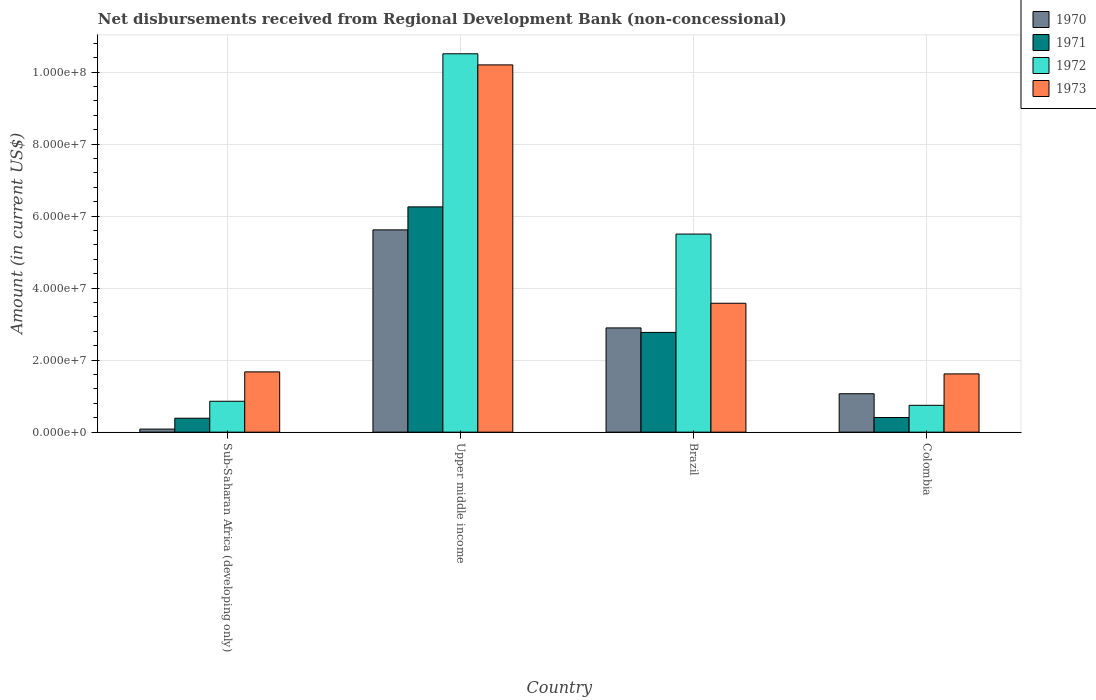Are the number of bars per tick equal to the number of legend labels?
Provide a succinct answer. Yes. How many bars are there on the 2nd tick from the left?
Offer a very short reply. 4. What is the label of the 3rd group of bars from the left?
Give a very brief answer. Brazil. In how many cases, is the number of bars for a given country not equal to the number of legend labels?
Your response must be concise. 0. What is the amount of disbursements received from Regional Development Bank in 1970 in Sub-Saharan Africa (developing only)?
Make the answer very short. 8.50e+05. Across all countries, what is the maximum amount of disbursements received from Regional Development Bank in 1970?
Your response must be concise. 5.62e+07. Across all countries, what is the minimum amount of disbursements received from Regional Development Bank in 1972?
Offer a very short reply. 7.45e+06. In which country was the amount of disbursements received from Regional Development Bank in 1972 maximum?
Make the answer very short. Upper middle income. In which country was the amount of disbursements received from Regional Development Bank in 1971 minimum?
Your answer should be compact. Sub-Saharan Africa (developing only). What is the total amount of disbursements received from Regional Development Bank in 1970 in the graph?
Offer a very short reply. 9.67e+07. What is the difference between the amount of disbursements received from Regional Development Bank in 1970 in Brazil and that in Sub-Saharan Africa (developing only)?
Your answer should be very brief. 2.81e+07. What is the difference between the amount of disbursements received from Regional Development Bank in 1971 in Upper middle income and the amount of disbursements received from Regional Development Bank in 1972 in Colombia?
Offer a very short reply. 5.51e+07. What is the average amount of disbursements received from Regional Development Bank in 1971 per country?
Give a very brief answer. 2.46e+07. What is the difference between the amount of disbursements received from Regional Development Bank of/in 1972 and amount of disbursements received from Regional Development Bank of/in 1973 in Colombia?
Your answer should be compact. -8.73e+06. In how many countries, is the amount of disbursements received from Regional Development Bank in 1971 greater than 84000000 US$?
Your response must be concise. 0. What is the ratio of the amount of disbursements received from Regional Development Bank in 1972 in Colombia to that in Upper middle income?
Offer a very short reply. 0.07. Is the difference between the amount of disbursements received from Regional Development Bank in 1972 in Colombia and Sub-Saharan Africa (developing only) greater than the difference between the amount of disbursements received from Regional Development Bank in 1973 in Colombia and Sub-Saharan Africa (developing only)?
Your response must be concise. No. What is the difference between the highest and the second highest amount of disbursements received from Regional Development Bank in 1971?
Keep it short and to the point. 5.85e+07. What is the difference between the highest and the lowest amount of disbursements received from Regional Development Bank in 1970?
Your response must be concise. 5.53e+07. In how many countries, is the amount of disbursements received from Regional Development Bank in 1970 greater than the average amount of disbursements received from Regional Development Bank in 1970 taken over all countries?
Your answer should be compact. 2. Is the sum of the amount of disbursements received from Regional Development Bank in 1973 in Brazil and Colombia greater than the maximum amount of disbursements received from Regional Development Bank in 1971 across all countries?
Provide a short and direct response. No. Is it the case that in every country, the sum of the amount of disbursements received from Regional Development Bank in 1972 and amount of disbursements received from Regional Development Bank in 1973 is greater than the sum of amount of disbursements received from Regional Development Bank in 1971 and amount of disbursements received from Regional Development Bank in 1970?
Your response must be concise. No. What does the 3rd bar from the right in Upper middle income represents?
Provide a succinct answer. 1971. Is it the case that in every country, the sum of the amount of disbursements received from Regional Development Bank in 1973 and amount of disbursements received from Regional Development Bank in 1971 is greater than the amount of disbursements received from Regional Development Bank in 1972?
Give a very brief answer. Yes. How many bars are there?
Offer a very short reply. 16. What is the difference between two consecutive major ticks on the Y-axis?
Provide a short and direct response. 2.00e+07. Are the values on the major ticks of Y-axis written in scientific E-notation?
Provide a short and direct response. Yes. Does the graph contain any zero values?
Provide a succinct answer. No. Does the graph contain grids?
Give a very brief answer. Yes. How many legend labels are there?
Provide a short and direct response. 4. What is the title of the graph?
Provide a succinct answer. Net disbursements received from Regional Development Bank (non-concessional). What is the label or title of the X-axis?
Make the answer very short. Country. What is the label or title of the Y-axis?
Ensure brevity in your answer.  Amount (in current US$). What is the Amount (in current US$) of 1970 in Sub-Saharan Africa (developing only)?
Keep it short and to the point. 8.50e+05. What is the Amount (in current US$) in 1971 in Sub-Saharan Africa (developing only)?
Give a very brief answer. 3.87e+06. What is the Amount (in current US$) in 1972 in Sub-Saharan Africa (developing only)?
Your answer should be compact. 8.58e+06. What is the Amount (in current US$) in 1973 in Sub-Saharan Africa (developing only)?
Your answer should be compact. 1.67e+07. What is the Amount (in current US$) of 1970 in Upper middle income?
Provide a succinct answer. 5.62e+07. What is the Amount (in current US$) in 1971 in Upper middle income?
Offer a terse response. 6.26e+07. What is the Amount (in current US$) in 1972 in Upper middle income?
Ensure brevity in your answer.  1.05e+08. What is the Amount (in current US$) in 1973 in Upper middle income?
Offer a terse response. 1.02e+08. What is the Amount (in current US$) in 1970 in Brazil?
Your answer should be very brief. 2.90e+07. What is the Amount (in current US$) of 1971 in Brazil?
Your answer should be very brief. 2.77e+07. What is the Amount (in current US$) of 1972 in Brazil?
Provide a succinct answer. 5.50e+07. What is the Amount (in current US$) of 1973 in Brazil?
Your answer should be very brief. 3.58e+07. What is the Amount (in current US$) in 1970 in Colombia?
Your response must be concise. 1.07e+07. What is the Amount (in current US$) of 1971 in Colombia?
Your answer should be compact. 4.06e+06. What is the Amount (in current US$) in 1972 in Colombia?
Make the answer very short. 7.45e+06. What is the Amount (in current US$) of 1973 in Colombia?
Provide a succinct answer. 1.62e+07. Across all countries, what is the maximum Amount (in current US$) of 1970?
Ensure brevity in your answer.  5.62e+07. Across all countries, what is the maximum Amount (in current US$) in 1971?
Your answer should be compact. 6.26e+07. Across all countries, what is the maximum Amount (in current US$) in 1972?
Your answer should be very brief. 1.05e+08. Across all countries, what is the maximum Amount (in current US$) of 1973?
Provide a short and direct response. 1.02e+08. Across all countries, what is the minimum Amount (in current US$) of 1970?
Ensure brevity in your answer.  8.50e+05. Across all countries, what is the minimum Amount (in current US$) of 1971?
Keep it short and to the point. 3.87e+06. Across all countries, what is the minimum Amount (in current US$) in 1972?
Keep it short and to the point. 7.45e+06. Across all countries, what is the minimum Amount (in current US$) of 1973?
Your answer should be very brief. 1.62e+07. What is the total Amount (in current US$) in 1970 in the graph?
Offer a very short reply. 9.67e+07. What is the total Amount (in current US$) of 1971 in the graph?
Offer a very short reply. 9.82e+07. What is the total Amount (in current US$) of 1972 in the graph?
Make the answer very short. 1.76e+08. What is the total Amount (in current US$) of 1973 in the graph?
Offer a terse response. 1.71e+08. What is the difference between the Amount (in current US$) in 1970 in Sub-Saharan Africa (developing only) and that in Upper middle income?
Your answer should be very brief. -5.53e+07. What is the difference between the Amount (in current US$) in 1971 in Sub-Saharan Africa (developing only) and that in Upper middle income?
Ensure brevity in your answer.  -5.87e+07. What is the difference between the Amount (in current US$) of 1972 in Sub-Saharan Africa (developing only) and that in Upper middle income?
Your response must be concise. -9.65e+07. What is the difference between the Amount (in current US$) in 1973 in Sub-Saharan Africa (developing only) and that in Upper middle income?
Keep it short and to the point. -8.53e+07. What is the difference between the Amount (in current US$) of 1970 in Sub-Saharan Africa (developing only) and that in Brazil?
Your answer should be compact. -2.81e+07. What is the difference between the Amount (in current US$) in 1971 in Sub-Saharan Africa (developing only) and that in Brazil?
Give a very brief answer. -2.38e+07. What is the difference between the Amount (in current US$) of 1972 in Sub-Saharan Africa (developing only) and that in Brazil?
Keep it short and to the point. -4.64e+07. What is the difference between the Amount (in current US$) of 1973 in Sub-Saharan Africa (developing only) and that in Brazil?
Provide a short and direct response. -1.91e+07. What is the difference between the Amount (in current US$) in 1970 in Sub-Saharan Africa (developing only) and that in Colombia?
Offer a very short reply. -9.82e+06. What is the difference between the Amount (in current US$) of 1971 in Sub-Saharan Africa (developing only) and that in Colombia?
Your answer should be very brief. -1.93e+05. What is the difference between the Amount (in current US$) in 1972 in Sub-Saharan Africa (developing only) and that in Colombia?
Give a very brief answer. 1.13e+06. What is the difference between the Amount (in current US$) of 1973 in Sub-Saharan Africa (developing only) and that in Colombia?
Provide a succinct answer. 5.57e+05. What is the difference between the Amount (in current US$) of 1970 in Upper middle income and that in Brazil?
Provide a short and direct response. 2.72e+07. What is the difference between the Amount (in current US$) of 1971 in Upper middle income and that in Brazil?
Provide a succinct answer. 3.49e+07. What is the difference between the Amount (in current US$) of 1972 in Upper middle income and that in Brazil?
Offer a very short reply. 5.01e+07. What is the difference between the Amount (in current US$) in 1973 in Upper middle income and that in Brazil?
Your response must be concise. 6.62e+07. What is the difference between the Amount (in current US$) of 1970 in Upper middle income and that in Colombia?
Give a very brief answer. 4.55e+07. What is the difference between the Amount (in current US$) of 1971 in Upper middle income and that in Colombia?
Make the answer very short. 5.85e+07. What is the difference between the Amount (in current US$) in 1972 in Upper middle income and that in Colombia?
Your answer should be very brief. 9.76e+07. What is the difference between the Amount (in current US$) in 1973 in Upper middle income and that in Colombia?
Your response must be concise. 8.58e+07. What is the difference between the Amount (in current US$) of 1970 in Brazil and that in Colombia?
Give a very brief answer. 1.83e+07. What is the difference between the Amount (in current US$) in 1971 in Brazil and that in Colombia?
Keep it short and to the point. 2.36e+07. What is the difference between the Amount (in current US$) of 1972 in Brazil and that in Colombia?
Provide a succinct answer. 4.76e+07. What is the difference between the Amount (in current US$) of 1973 in Brazil and that in Colombia?
Ensure brevity in your answer.  1.96e+07. What is the difference between the Amount (in current US$) in 1970 in Sub-Saharan Africa (developing only) and the Amount (in current US$) in 1971 in Upper middle income?
Ensure brevity in your answer.  -6.17e+07. What is the difference between the Amount (in current US$) in 1970 in Sub-Saharan Africa (developing only) and the Amount (in current US$) in 1972 in Upper middle income?
Your answer should be very brief. -1.04e+08. What is the difference between the Amount (in current US$) in 1970 in Sub-Saharan Africa (developing only) and the Amount (in current US$) in 1973 in Upper middle income?
Ensure brevity in your answer.  -1.01e+08. What is the difference between the Amount (in current US$) in 1971 in Sub-Saharan Africa (developing only) and the Amount (in current US$) in 1972 in Upper middle income?
Keep it short and to the point. -1.01e+08. What is the difference between the Amount (in current US$) of 1971 in Sub-Saharan Africa (developing only) and the Amount (in current US$) of 1973 in Upper middle income?
Offer a terse response. -9.81e+07. What is the difference between the Amount (in current US$) in 1972 in Sub-Saharan Africa (developing only) and the Amount (in current US$) in 1973 in Upper middle income?
Your answer should be very brief. -9.34e+07. What is the difference between the Amount (in current US$) in 1970 in Sub-Saharan Africa (developing only) and the Amount (in current US$) in 1971 in Brazil?
Keep it short and to the point. -2.69e+07. What is the difference between the Amount (in current US$) in 1970 in Sub-Saharan Africa (developing only) and the Amount (in current US$) in 1972 in Brazil?
Provide a short and direct response. -5.42e+07. What is the difference between the Amount (in current US$) in 1970 in Sub-Saharan Africa (developing only) and the Amount (in current US$) in 1973 in Brazil?
Give a very brief answer. -3.50e+07. What is the difference between the Amount (in current US$) in 1971 in Sub-Saharan Africa (developing only) and the Amount (in current US$) in 1972 in Brazil?
Offer a very short reply. -5.12e+07. What is the difference between the Amount (in current US$) of 1971 in Sub-Saharan Africa (developing only) and the Amount (in current US$) of 1973 in Brazil?
Make the answer very short. -3.19e+07. What is the difference between the Amount (in current US$) of 1972 in Sub-Saharan Africa (developing only) and the Amount (in current US$) of 1973 in Brazil?
Give a very brief answer. -2.72e+07. What is the difference between the Amount (in current US$) in 1970 in Sub-Saharan Africa (developing only) and the Amount (in current US$) in 1971 in Colombia?
Provide a short and direct response. -3.21e+06. What is the difference between the Amount (in current US$) of 1970 in Sub-Saharan Africa (developing only) and the Amount (in current US$) of 1972 in Colombia?
Your answer should be very brief. -6.60e+06. What is the difference between the Amount (in current US$) of 1970 in Sub-Saharan Africa (developing only) and the Amount (in current US$) of 1973 in Colombia?
Provide a succinct answer. -1.53e+07. What is the difference between the Amount (in current US$) of 1971 in Sub-Saharan Africa (developing only) and the Amount (in current US$) of 1972 in Colombia?
Keep it short and to the point. -3.58e+06. What is the difference between the Amount (in current US$) of 1971 in Sub-Saharan Africa (developing only) and the Amount (in current US$) of 1973 in Colombia?
Ensure brevity in your answer.  -1.23e+07. What is the difference between the Amount (in current US$) in 1972 in Sub-Saharan Africa (developing only) and the Amount (in current US$) in 1973 in Colombia?
Offer a terse response. -7.60e+06. What is the difference between the Amount (in current US$) in 1970 in Upper middle income and the Amount (in current US$) in 1971 in Brazil?
Give a very brief answer. 2.85e+07. What is the difference between the Amount (in current US$) of 1970 in Upper middle income and the Amount (in current US$) of 1972 in Brazil?
Your response must be concise. 1.16e+06. What is the difference between the Amount (in current US$) in 1970 in Upper middle income and the Amount (in current US$) in 1973 in Brazil?
Offer a terse response. 2.04e+07. What is the difference between the Amount (in current US$) in 1971 in Upper middle income and the Amount (in current US$) in 1972 in Brazil?
Make the answer very short. 7.55e+06. What is the difference between the Amount (in current US$) of 1971 in Upper middle income and the Amount (in current US$) of 1973 in Brazil?
Your answer should be compact. 2.68e+07. What is the difference between the Amount (in current US$) of 1972 in Upper middle income and the Amount (in current US$) of 1973 in Brazil?
Provide a succinct answer. 6.93e+07. What is the difference between the Amount (in current US$) of 1970 in Upper middle income and the Amount (in current US$) of 1971 in Colombia?
Your response must be concise. 5.21e+07. What is the difference between the Amount (in current US$) of 1970 in Upper middle income and the Amount (in current US$) of 1972 in Colombia?
Your answer should be very brief. 4.87e+07. What is the difference between the Amount (in current US$) of 1970 in Upper middle income and the Amount (in current US$) of 1973 in Colombia?
Offer a terse response. 4.00e+07. What is the difference between the Amount (in current US$) of 1971 in Upper middle income and the Amount (in current US$) of 1972 in Colombia?
Provide a short and direct response. 5.51e+07. What is the difference between the Amount (in current US$) in 1971 in Upper middle income and the Amount (in current US$) in 1973 in Colombia?
Keep it short and to the point. 4.64e+07. What is the difference between the Amount (in current US$) of 1972 in Upper middle income and the Amount (in current US$) of 1973 in Colombia?
Your answer should be compact. 8.89e+07. What is the difference between the Amount (in current US$) of 1970 in Brazil and the Amount (in current US$) of 1971 in Colombia?
Offer a terse response. 2.49e+07. What is the difference between the Amount (in current US$) in 1970 in Brazil and the Amount (in current US$) in 1972 in Colombia?
Provide a succinct answer. 2.15e+07. What is the difference between the Amount (in current US$) of 1970 in Brazil and the Amount (in current US$) of 1973 in Colombia?
Your response must be concise. 1.28e+07. What is the difference between the Amount (in current US$) of 1971 in Brazil and the Amount (in current US$) of 1972 in Colombia?
Keep it short and to the point. 2.03e+07. What is the difference between the Amount (in current US$) of 1971 in Brazil and the Amount (in current US$) of 1973 in Colombia?
Provide a succinct answer. 1.15e+07. What is the difference between the Amount (in current US$) in 1972 in Brazil and the Amount (in current US$) in 1973 in Colombia?
Make the answer very short. 3.88e+07. What is the average Amount (in current US$) of 1970 per country?
Give a very brief answer. 2.42e+07. What is the average Amount (in current US$) of 1971 per country?
Offer a terse response. 2.46e+07. What is the average Amount (in current US$) in 1972 per country?
Give a very brief answer. 4.40e+07. What is the average Amount (in current US$) of 1973 per country?
Make the answer very short. 4.27e+07. What is the difference between the Amount (in current US$) in 1970 and Amount (in current US$) in 1971 in Sub-Saharan Africa (developing only)?
Keep it short and to the point. -3.02e+06. What is the difference between the Amount (in current US$) in 1970 and Amount (in current US$) in 1972 in Sub-Saharan Africa (developing only)?
Ensure brevity in your answer.  -7.73e+06. What is the difference between the Amount (in current US$) in 1970 and Amount (in current US$) in 1973 in Sub-Saharan Africa (developing only)?
Offer a terse response. -1.59e+07. What is the difference between the Amount (in current US$) in 1971 and Amount (in current US$) in 1972 in Sub-Saharan Africa (developing only)?
Your answer should be very brief. -4.71e+06. What is the difference between the Amount (in current US$) of 1971 and Amount (in current US$) of 1973 in Sub-Saharan Africa (developing only)?
Give a very brief answer. -1.29e+07. What is the difference between the Amount (in current US$) of 1972 and Amount (in current US$) of 1973 in Sub-Saharan Africa (developing only)?
Your response must be concise. -8.16e+06. What is the difference between the Amount (in current US$) in 1970 and Amount (in current US$) in 1971 in Upper middle income?
Your answer should be compact. -6.39e+06. What is the difference between the Amount (in current US$) of 1970 and Amount (in current US$) of 1972 in Upper middle income?
Provide a succinct answer. -4.89e+07. What is the difference between the Amount (in current US$) of 1970 and Amount (in current US$) of 1973 in Upper middle income?
Ensure brevity in your answer.  -4.58e+07. What is the difference between the Amount (in current US$) in 1971 and Amount (in current US$) in 1972 in Upper middle income?
Offer a very short reply. -4.25e+07. What is the difference between the Amount (in current US$) of 1971 and Amount (in current US$) of 1973 in Upper middle income?
Keep it short and to the point. -3.94e+07. What is the difference between the Amount (in current US$) in 1972 and Amount (in current US$) in 1973 in Upper middle income?
Keep it short and to the point. 3.08e+06. What is the difference between the Amount (in current US$) in 1970 and Amount (in current US$) in 1971 in Brazil?
Make the answer very short. 1.25e+06. What is the difference between the Amount (in current US$) of 1970 and Amount (in current US$) of 1972 in Brazil?
Give a very brief answer. -2.61e+07. What is the difference between the Amount (in current US$) of 1970 and Amount (in current US$) of 1973 in Brazil?
Your answer should be very brief. -6.85e+06. What is the difference between the Amount (in current US$) in 1971 and Amount (in current US$) in 1972 in Brazil?
Provide a short and direct response. -2.73e+07. What is the difference between the Amount (in current US$) in 1971 and Amount (in current US$) in 1973 in Brazil?
Provide a succinct answer. -8.10e+06. What is the difference between the Amount (in current US$) in 1972 and Amount (in current US$) in 1973 in Brazil?
Your answer should be compact. 1.92e+07. What is the difference between the Amount (in current US$) of 1970 and Amount (in current US$) of 1971 in Colombia?
Offer a terse response. 6.61e+06. What is the difference between the Amount (in current US$) in 1970 and Amount (in current US$) in 1972 in Colombia?
Provide a succinct answer. 3.22e+06. What is the difference between the Amount (in current US$) in 1970 and Amount (in current US$) in 1973 in Colombia?
Your answer should be compact. -5.51e+06. What is the difference between the Amount (in current US$) in 1971 and Amount (in current US$) in 1972 in Colombia?
Ensure brevity in your answer.  -3.39e+06. What is the difference between the Amount (in current US$) of 1971 and Amount (in current US$) of 1973 in Colombia?
Keep it short and to the point. -1.21e+07. What is the difference between the Amount (in current US$) in 1972 and Amount (in current US$) in 1973 in Colombia?
Offer a very short reply. -8.73e+06. What is the ratio of the Amount (in current US$) in 1970 in Sub-Saharan Africa (developing only) to that in Upper middle income?
Make the answer very short. 0.02. What is the ratio of the Amount (in current US$) in 1971 in Sub-Saharan Africa (developing only) to that in Upper middle income?
Offer a very short reply. 0.06. What is the ratio of the Amount (in current US$) in 1972 in Sub-Saharan Africa (developing only) to that in Upper middle income?
Give a very brief answer. 0.08. What is the ratio of the Amount (in current US$) in 1973 in Sub-Saharan Africa (developing only) to that in Upper middle income?
Your response must be concise. 0.16. What is the ratio of the Amount (in current US$) in 1970 in Sub-Saharan Africa (developing only) to that in Brazil?
Keep it short and to the point. 0.03. What is the ratio of the Amount (in current US$) of 1971 in Sub-Saharan Africa (developing only) to that in Brazil?
Your answer should be compact. 0.14. What is the ratio of the Amount (in current US$) in 1972 in Sub-Saharan Africa (developing only) to that in Brazil?
Offer a terse response. 0.16. What is the ratio of the Amount (in current US$) of 1973 in Sub-Saharan Africa (developing only) to that in Brazil?
Provide a succinct answer. 0.47. What is the ratio of the Amount (in current US$) in 1970 in Sub-Saharan Africa (developing only) to that in Colombia?
Offer a terse response. 0.08. What is the ratio of the Amount (in current US$) of 1971 in Sub-Saharan Africa (developing only) to that in Colombia?
Your answer should be compact. 0.95. What is the ratio of the Amount (in current US$) of 1972 in Sub-Saharan Africa (developing only) to that in Colombia?
Give a very brief answer. 1.15. What is the ratio of the Amount (in current US$) in 1973 in Sub-Saharan Africa (developing only) to that in Colombia?
Make the answer very short. 1.03. What is the ratio of the Amount (in current US$) in 1970 in Upper middle income to that in Brazil?
Ensure brevity in your answer.  1.94. What is the ratio of the Amount (in current US$) of 1971 in Upper middle income to that in Brazil?
Offer a terse response. 2.26. What is the ratio of the Amount (in current US$) in 1972 in Upper middle income to that in Brazil?
Provide a short and direct response. 1.91. What is the ratio of the Amount (in current US$) in 1973 in Upper middle income to that in Brazil?
Give a very brief answer. 2.85. What is the ratio of the Amount (in current US$) in 1970 in Upper middle income to that in Colombia?
Give a very brief answer. 5.27. What is the ratio of the Amount (in current US$) in 1971 in Upper middle income to that in Colombia?
Your answer should be very brief. 15.4. What is the ratio of the Amount (in current US$) in 1972 in Upper middle income to that in Colombia?
Make the answer very short. 14.11. What is the ratio of the Amount (in current US$) of 1973 in Upper middle income to that in Colombia?
Your response must be concise. 6.3. What is the ratio of the Amount (in current US$) in 1970 in Brazil to that in Colombia?
Offer a terse response. 2.71. What is the ratio of the Amount (in current US$) in 1971 in Brazil to that in Colombia?
Your answer should be very brief. 6.82. What is the ratio of the Amount (in current US$) in 1972 in Brazil to that in Colombia?
Give a very brief answer. 7.39. What is the ratio of the Amount (in current US$) of 1973 in Brazil to that in Colombia?
Your answer should be very brief. 2.21. What is the difference between the highest and the second highest Amount (in current US$) of 1970?
Your answer should be compact. 2.72e+07. What is the difference between the highest and the second highest Amount (in current US$) of 1971?
Give a very brief answer. 3.49e+07. What is the difference between the highest and the second highest Amount (in current US$) of 1972?
Your answer should be compact. 5.01e+07. What is the difference between the highest and the second highest Amount (in current US$) in 1973?
Ensure brevity in your answer.  6.62e+07. What is the difference between the highest and the lowest Amount (in current US$) of 1970?
Your answer should be very brief. 5.53e+07. What is the difference between the highest and the lowest Amount (in current US$) of 1971?
Make the answer very short. 5.87e+07. What is the difference between the highest and the lowest Amount (in current US$) in 1972?
Your response must be concise. 9.76e+07. What is the difference between the highest and the lowest Amount (in current US$) of 1973?
Offer a very short reply. 8.58e+07. 